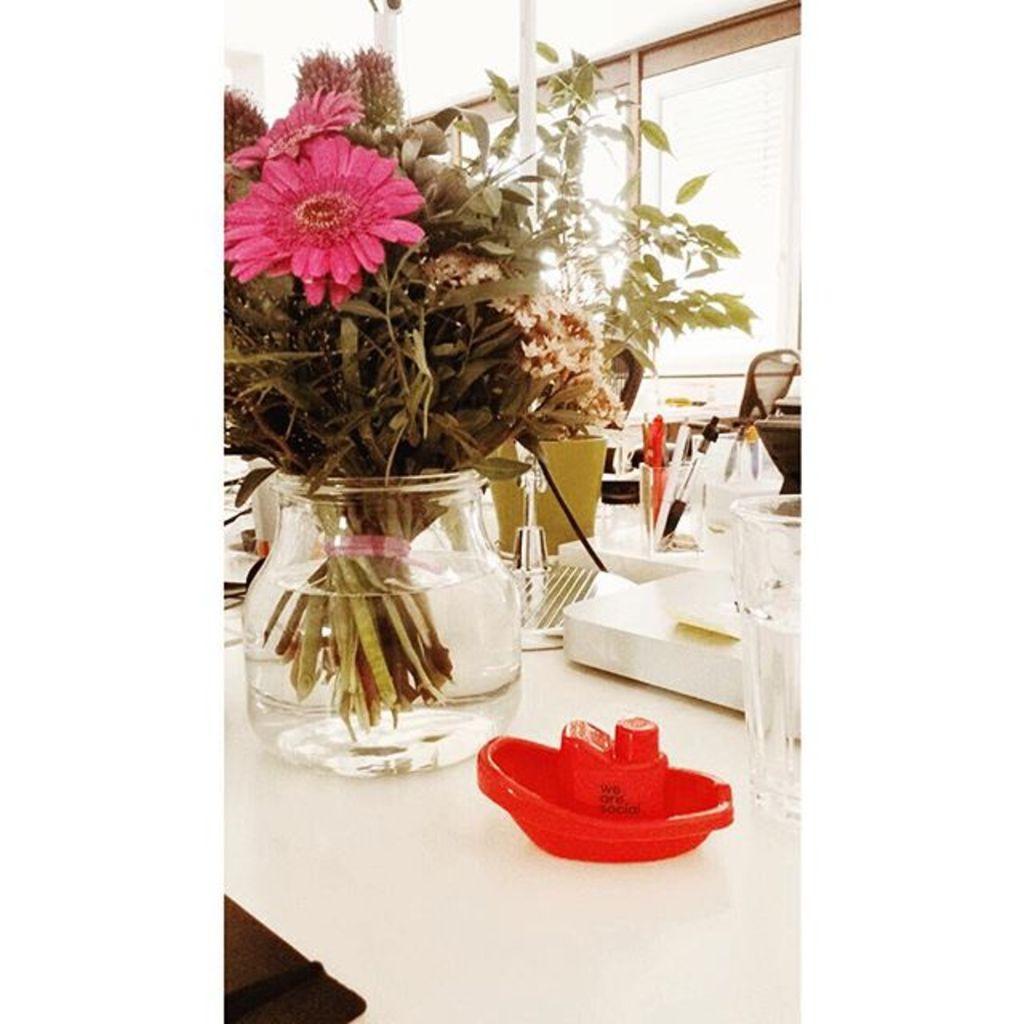Please provide a concise description of this image. In this image we can see some flowers and leaves placed in a bowl containing water. On the right side of the image we can see some objects, a glass and pens in a container are placed on the table. In the background, we can see some chairs, windows and some poles. 